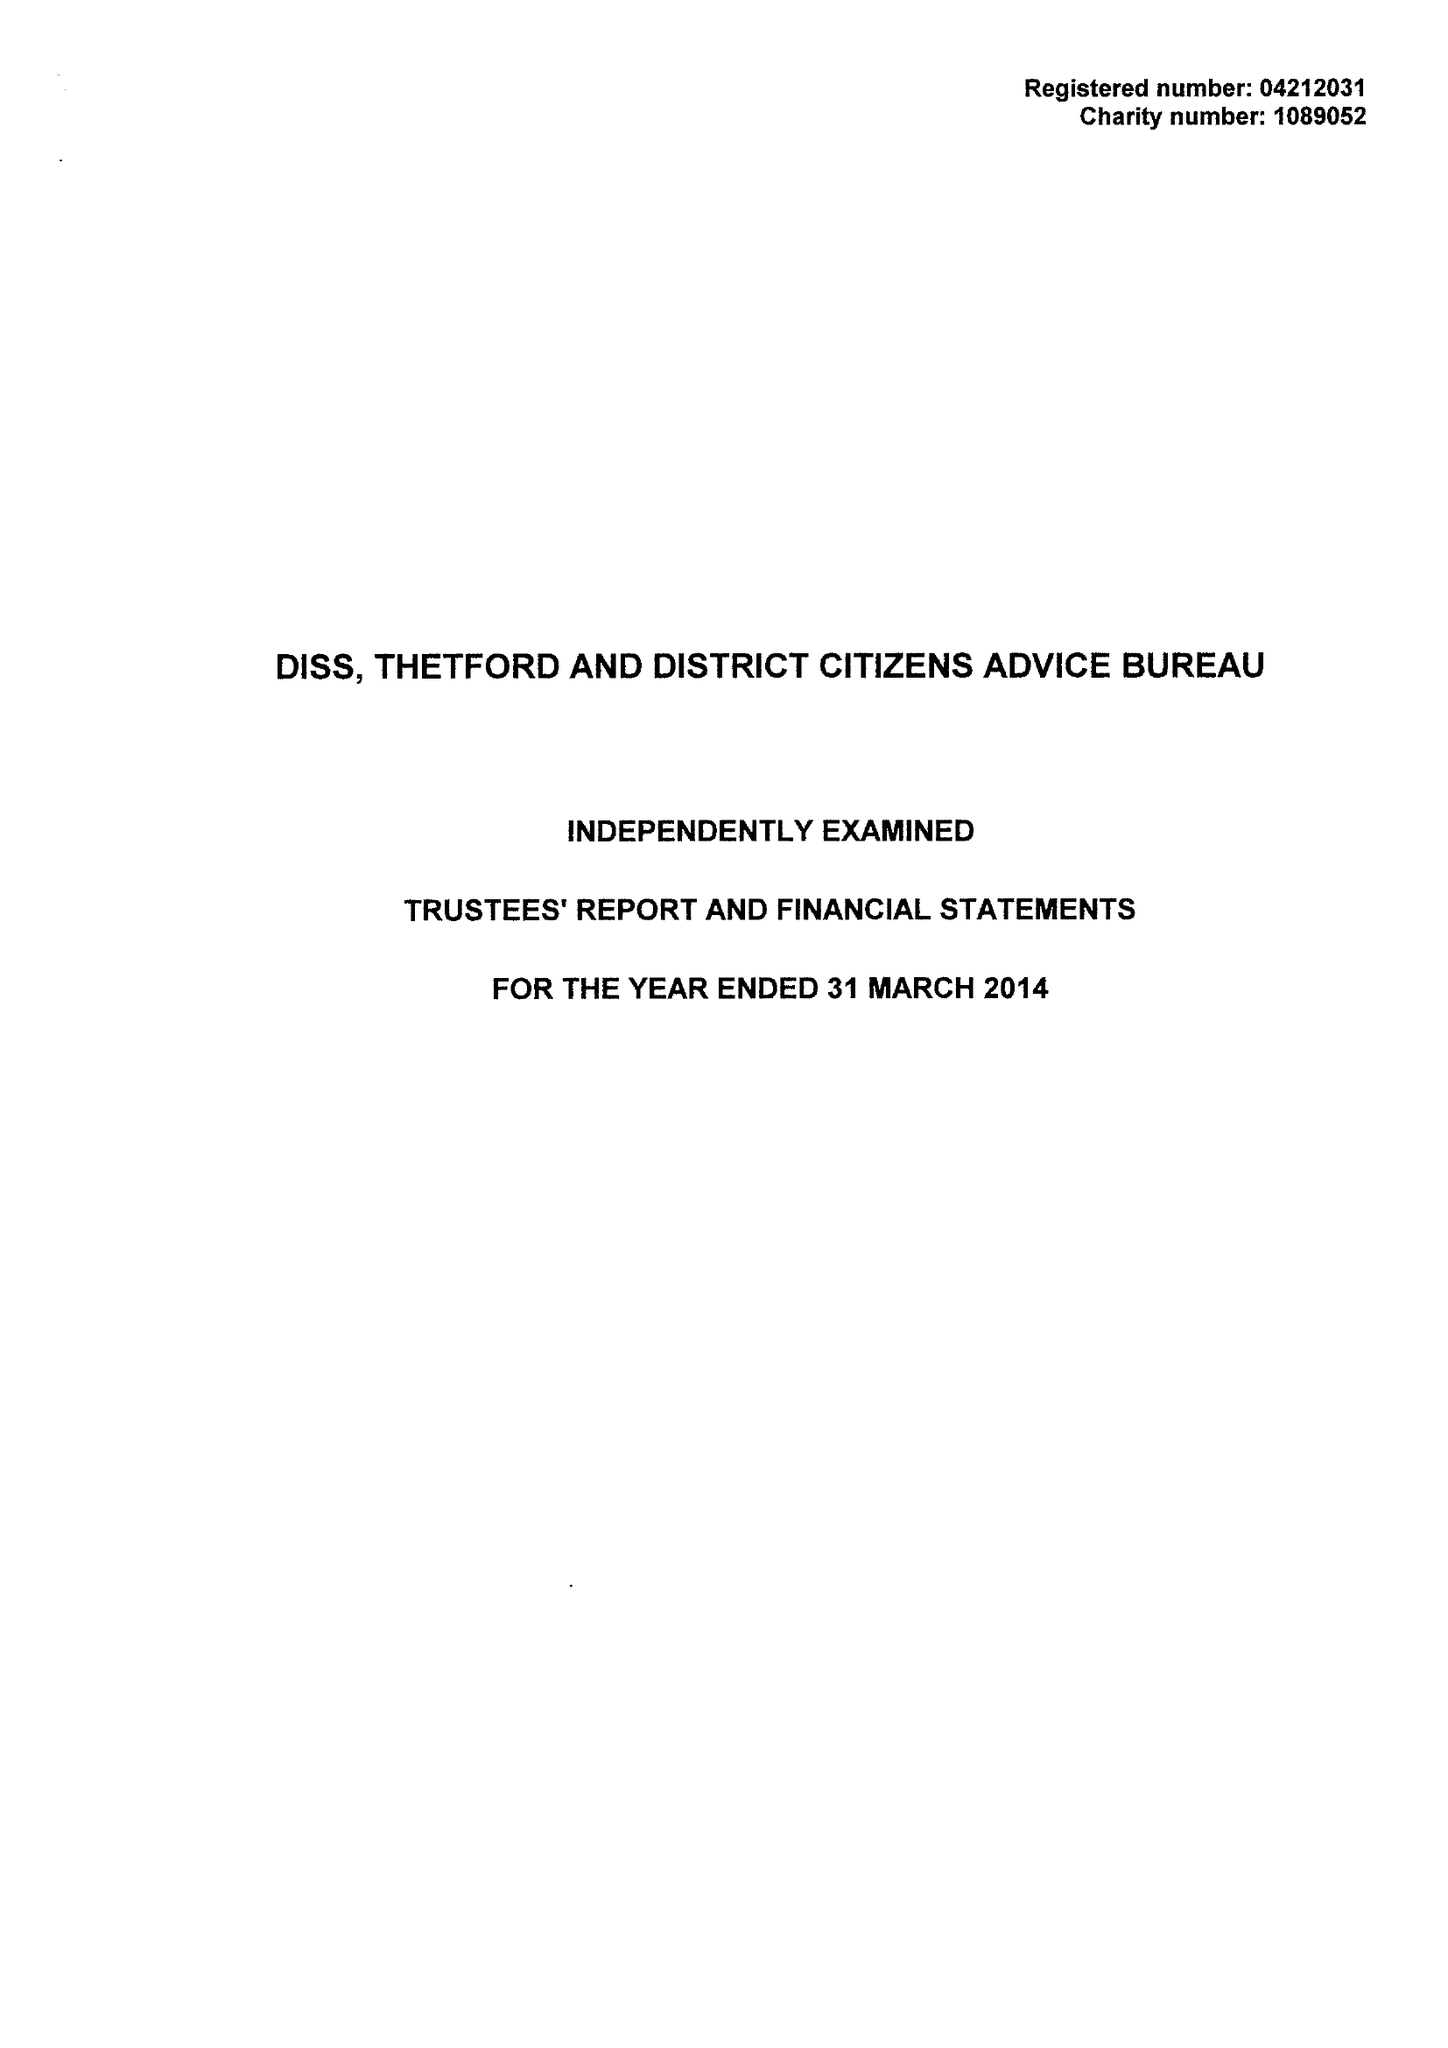What is the value for the spending_annually_in_british_pounds?
Answer the question using a single word or phrase. 275488.00 